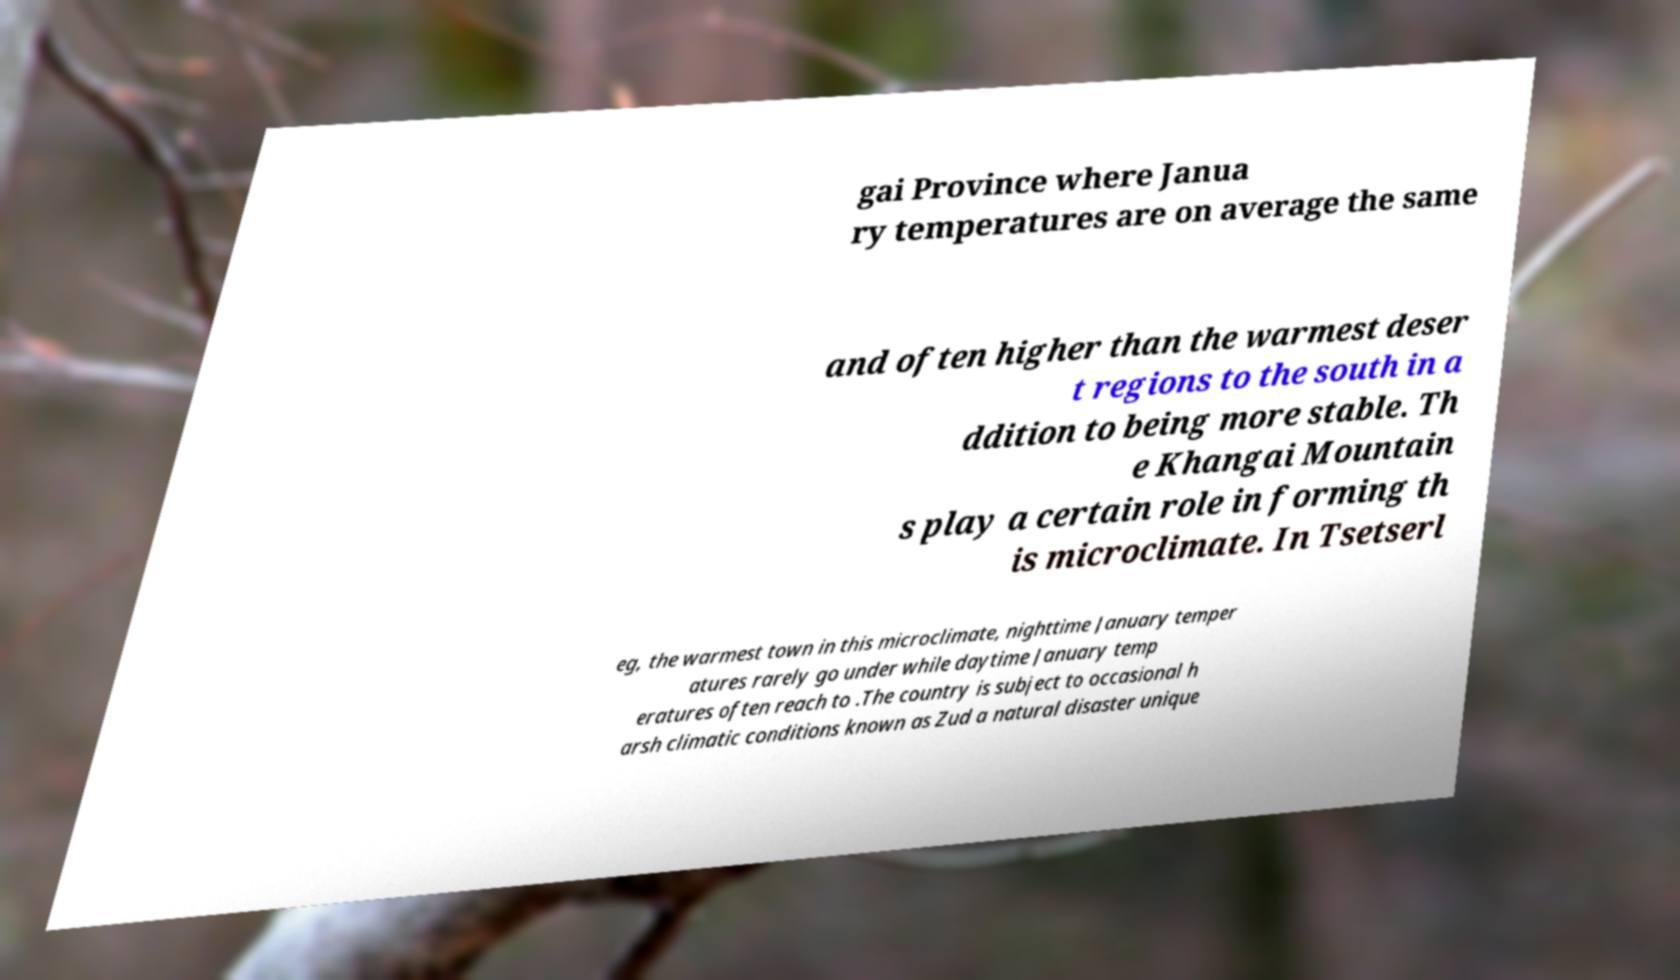Could you extract and type out the text from this image? gai Province where Janua ry temperatures are on average the same and often higher than the warmest deser t regions to the south in a ddition to being more stable. Th e Khangai Mountain s play a certain role in forming th is microclimate. In Tsetserl eg, the warmest town in this microclimate, nighttime January temper atures rarely go under while daytime January temp eratures often reach to .The country is subject to occasional h arsh climatic conditions known as Zud a natural disaster unique 